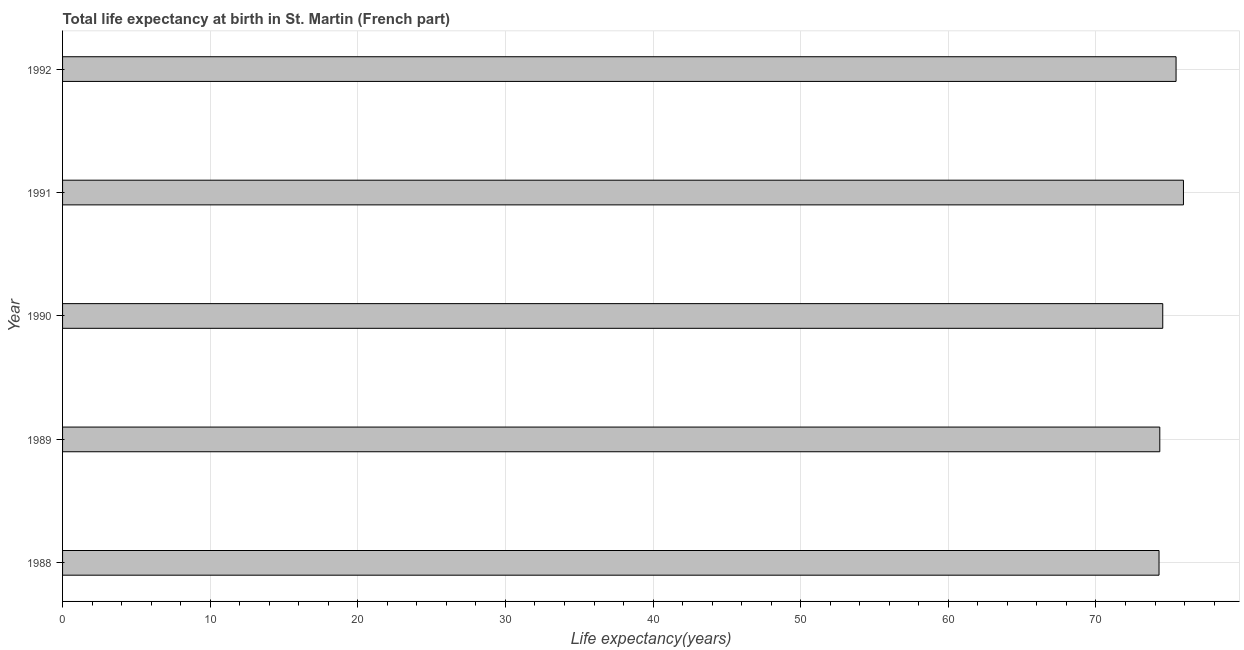What is the title of the graph?
Offer a very short reply. Total life expectancy at birth in St. Martin (French part). What is the label or title of the X-axis?
Offer a very short reply. Life expectancy(years). What is the life expectancy at birth in 1991?
Keep it short and to the point. 75.92. Across all years, what is the maximum life expectancy at birth?
Offer a terse response. 75.92. Across all years, what is the minimum life expectancy at birth?
Your response must be concise. 74.27. In which year was the life expectancy at birth minimum?
Make the answer very short. 1988. What is the sum of the life expectancy at birth?
Your answer should be very brief. 374.46. What is the difference between the life expectancy at birth in 1989 and 1991?
Your response must be concise. -1.6. What is the average life expectancy at birth per year?
Give a very brief answer. 74.89. What is the median life expectancy at birth?
Keep it short and to the point. 74.52. Do a majority of the years between 1990 and 1988 (inclusive) have life expectancy at birth greater than 58 years?
Give a very brief answer. Yes. Is the difference between the life expectancy at birth in 1989 and 1992 greater than the difference between any two years?
Offer a very short reply. No. Is the sum of the life expectancy at birth in 1990 and 1992 greater than the maximum life expectancy at birth across all years?
Provide a succinct answer. Yes. What is the difference between the highest and the lowest life expectancy at birth?
Your answer should be very brief. 1.65. In how many years, is the life expectancy at birth greater than the average life expectancy at birth taken over all years?
Provide a succinct answer. 2. How many years are there in the graph?
Your answer should be compact. 5. What is the difference between two consecutive major ticks on the X-axis?
Your response must be concise. 10. What is the Life expectancy(years) of 1988?
Provide a short and direct response. 74.27. What is the Life expectancy(years) of 1989?
Offer a terse response. 74.32. What is the Life expectancy(years) in 1990?
Offer a terse response. 74.52. What is the Life expectancy(years) in 1991?
Provide a succinct answer. 75.92. What is the Life expectancy(years) in 1992?
Provide a short and direct response. 75.42. What is the difference between the Life expectancy(years) in 1988 and 1989?
Give a very brief answer. -0.05. What is the difference between the Life expectancy(years) in 1988 and 1990?
Keep it short and to the point. -0.25. What is the difference between the Life expectancy(years) in 1988 and 1991?
Provide a succinct answer. -1.65. What is the difference between the Life expectancy(years) in 1988 and 1992?
Provide a succinct answer. -1.15. What is the difference between the Life expectancy(years) in 1989 and 1990?
Keep it short and to the point. -0.2. What is the difference between the Life expectancy(years) in 1989 and 1991?
Give a very brief answer. -1.6. What is the difference between the Life expectancy(years) in 1989 and 1992?
Provide a succinct answer. -1.1. What is the difference between the Life expectancy(years) in 1990 and 1991?
Provide a short and direct response. -1.4. What is the difference between the Life expectancy(years) in 1990 and 1992?
Your answer should be compact. -0.9. What is the difference between the Life expectancy(years) in 1991 and 1992?
Offer a very short reply. 0.5. What is the ratio of the Life expectancy(years) in 1988 to that in 1989?
Your response must be concise. 1. What is the ratio of the Life expectancy(years) in 1988 to that in 1991?
Make the answer very short. 0.98. What is the ratio of the Life expectancy(years) in 1989 to that in 1992?
Ensure brevity in your answer.  0.98. What is the ratio of the Life expectancy(years) in 1990 to that in 1991?
Your response must be concise. 0.98. What is the ratio of the Life expectancy(years) in 1990 to that in 1992?
Make the answer very short. 0.99. What is the ratio of the Life expectancy(years) in 1991 to that in 1992?
Provide a succinct answer. 1.01. 